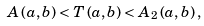<formula> <loc_0><loc_0><loc_500><loc_500>A \left ( a , b \right ) < T \left ( a , b \right ) < A _ { 2 } \left ( a , b \right ) ,</formula> 